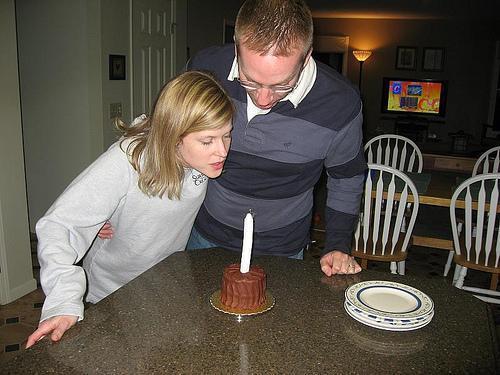How many people are in the image?
Give a very brief answer. 2. How many people are there?
Give a very brief answer. 2. How many chairs are there?
Give a very brief answer. 2. 